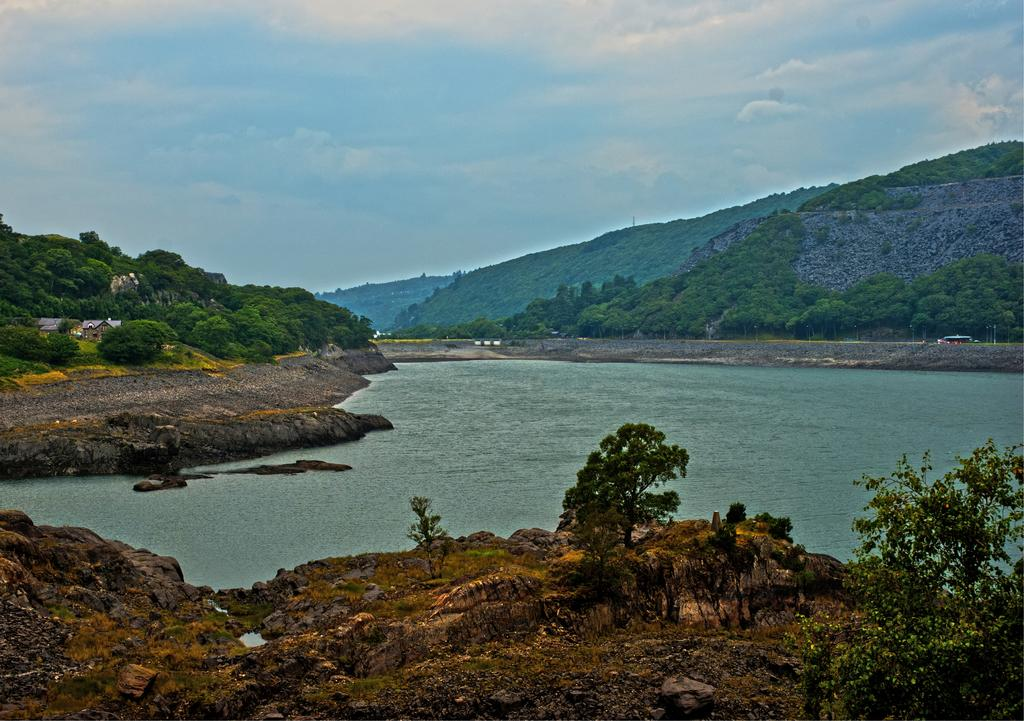What type of natural elements can be seen in the image? There are trees, rocks, water, and mountains visible in the image. What type of man-made structure is present in the image? There is a house in the image. What is visible in the background of the image? The sky is visible in the background of the image, and there are clouds in the sky. What decision did the room make in the image? There is no room present in the image, and therefore no decision can be made by a room. 